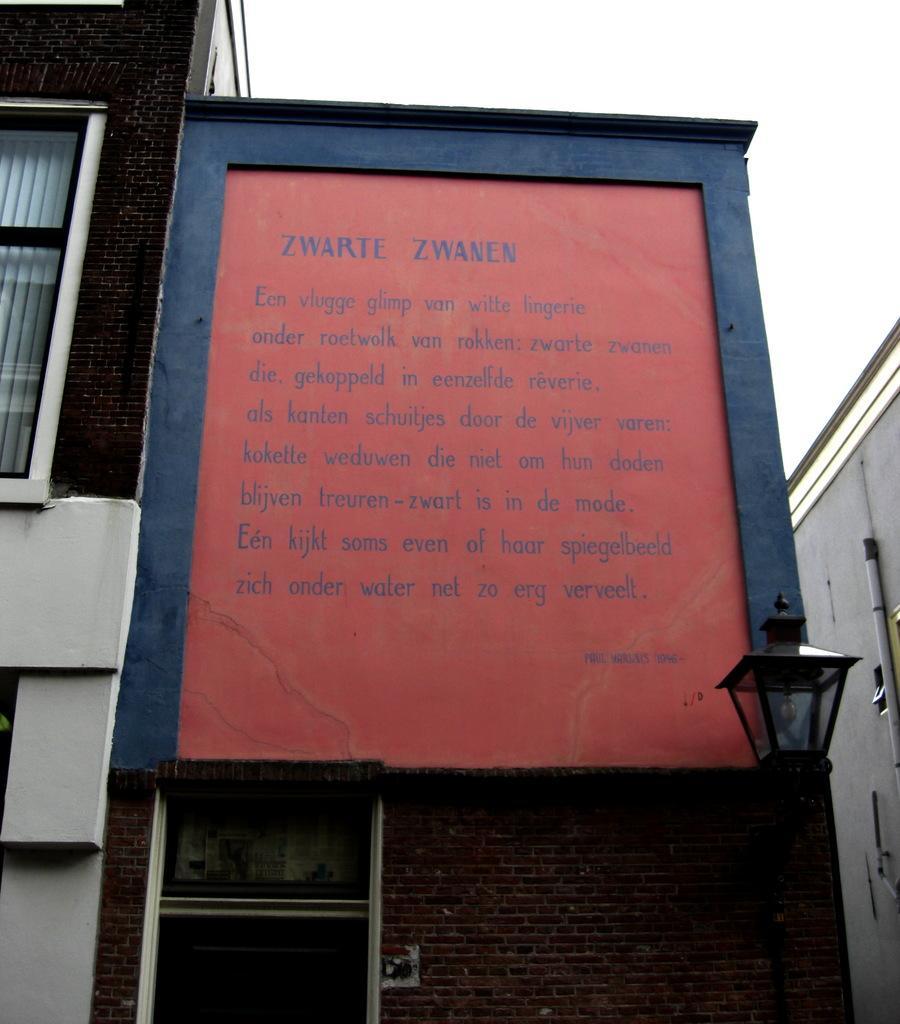In one or two sentences, can you explain what this image depicts? In this picture there is a poster which is placed on the wall. At the bottom there is a door. On the left I can see the window blinds and window. On the right there is a building. In the top right I can see the sky. In the bottom right corner there is a street light near to the brick wall. 